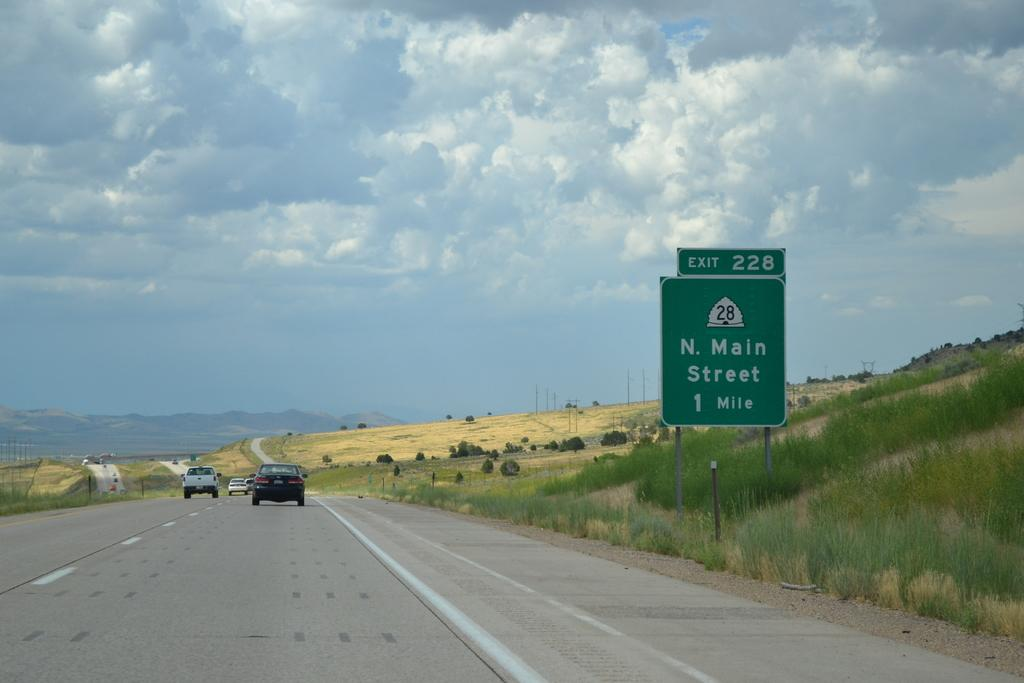<image>
Share a concise interpretation of the image provided. The sign on the freeway indicates that the N. Main Street exit is in one mile ahead. 